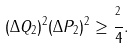Convert formula to latex. <formula><loc_0><loc_0><loc_500><loc_500>( \Delta Q _ { 2 } ) ^ { 2 } ( \Delta P _ { 2 } ) ^ { 2 } \geq \frac { { } ^ { 2 } } { 4 } .</formula> 